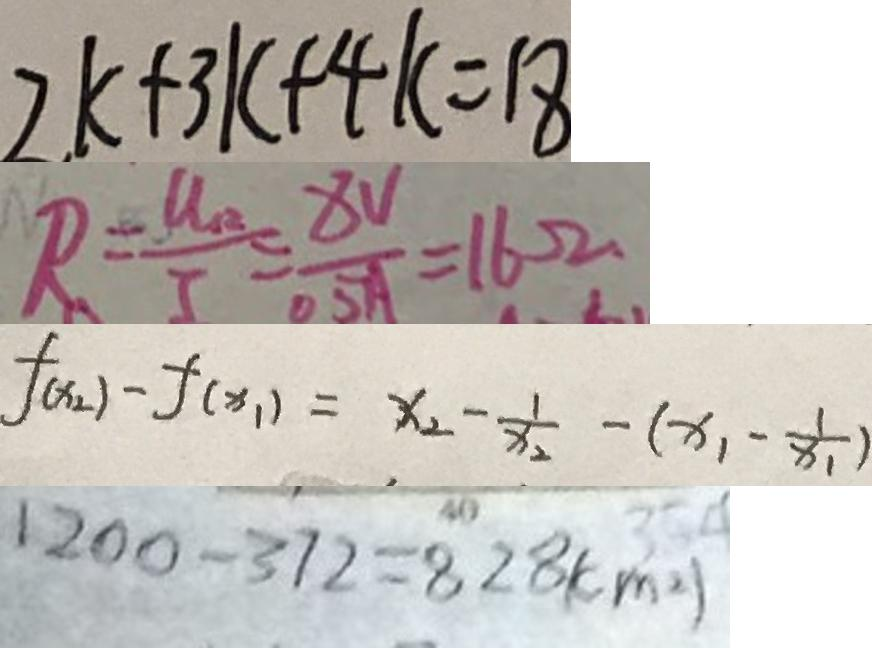<formula> <loc_0><loc_0><loc_500><loc_500>2 k + 3 k + 4 k = 1 8 
 R = \frac { U _ { R } } { I } = \frac { 8 V } { 0 . 5 A } = 1 6 \Omega 
 f ( x _ { 2 } ) - f ( x _ { 1 } ) = x _ { 2 } - \frac { 1 } { x _ { 1 } } - ( x _ { 1 } - \frac { 1 } { x _ { 1 } } ) 
 1 2 0 0 - 3 7 2 = 8 2 8 ( c m ^ { 2 } )</formula> 